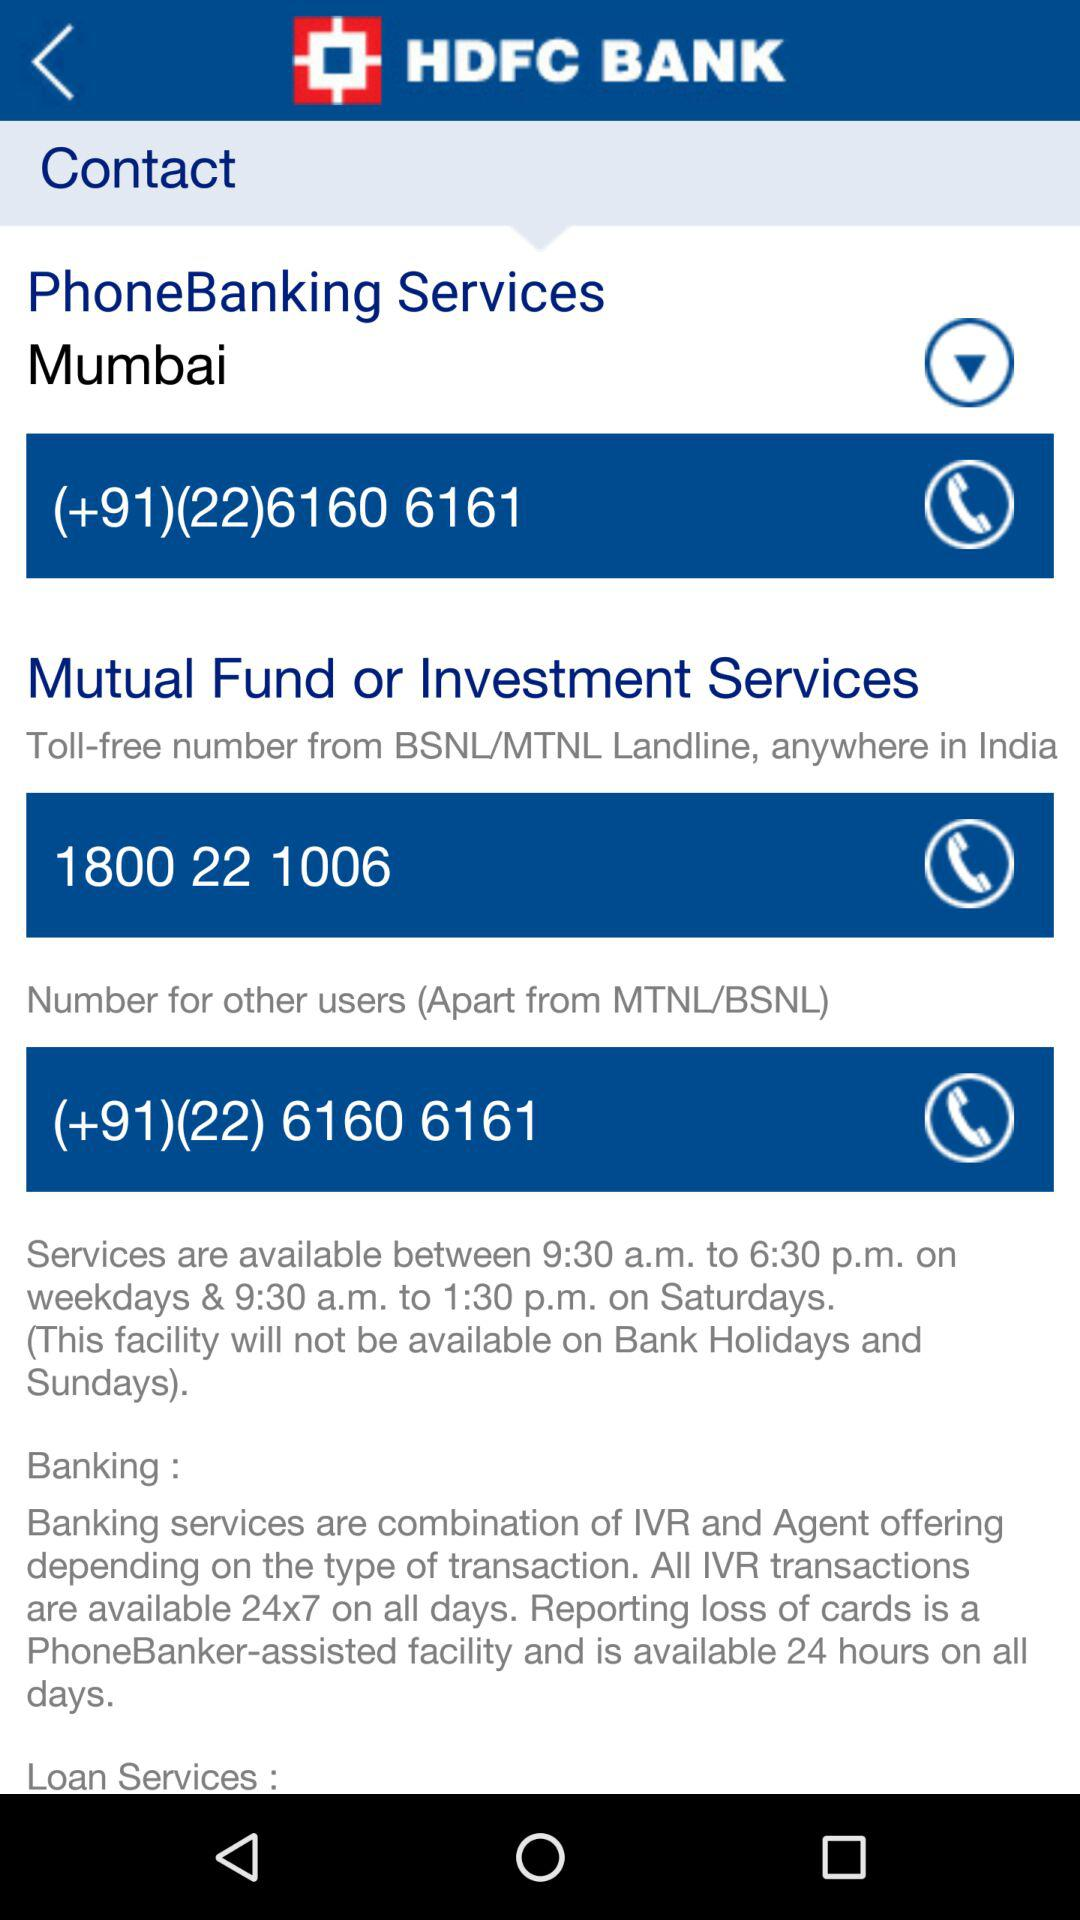What is the service timing? The service timing is between 9:30 a.m. to 6:30 p.m. on weekdays and 9:30 a.m. to 1:30 p.m. on Saturdays. (This facility will not be available on bank holidays and Sundays). 